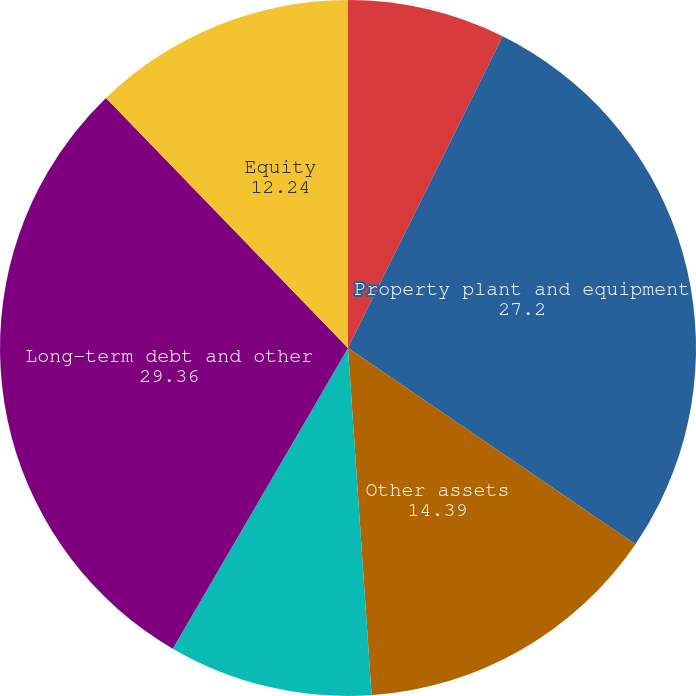Convert chart to OTSL. <chart><loc_0><loc_0><loc_500><loc_500><pie_chart><fcel>Current assets<fcel>Property plant and equipment<fcel>Other assets<fcel>Current liabilities<fcel>Long-term debt and other<fcel>Equity<nl><fcel>7.33%<fcel>27.2%<fcel>14.39%<fcel>9.48%<fcel>29.36%<fcel>12.24%<nl></chart> 